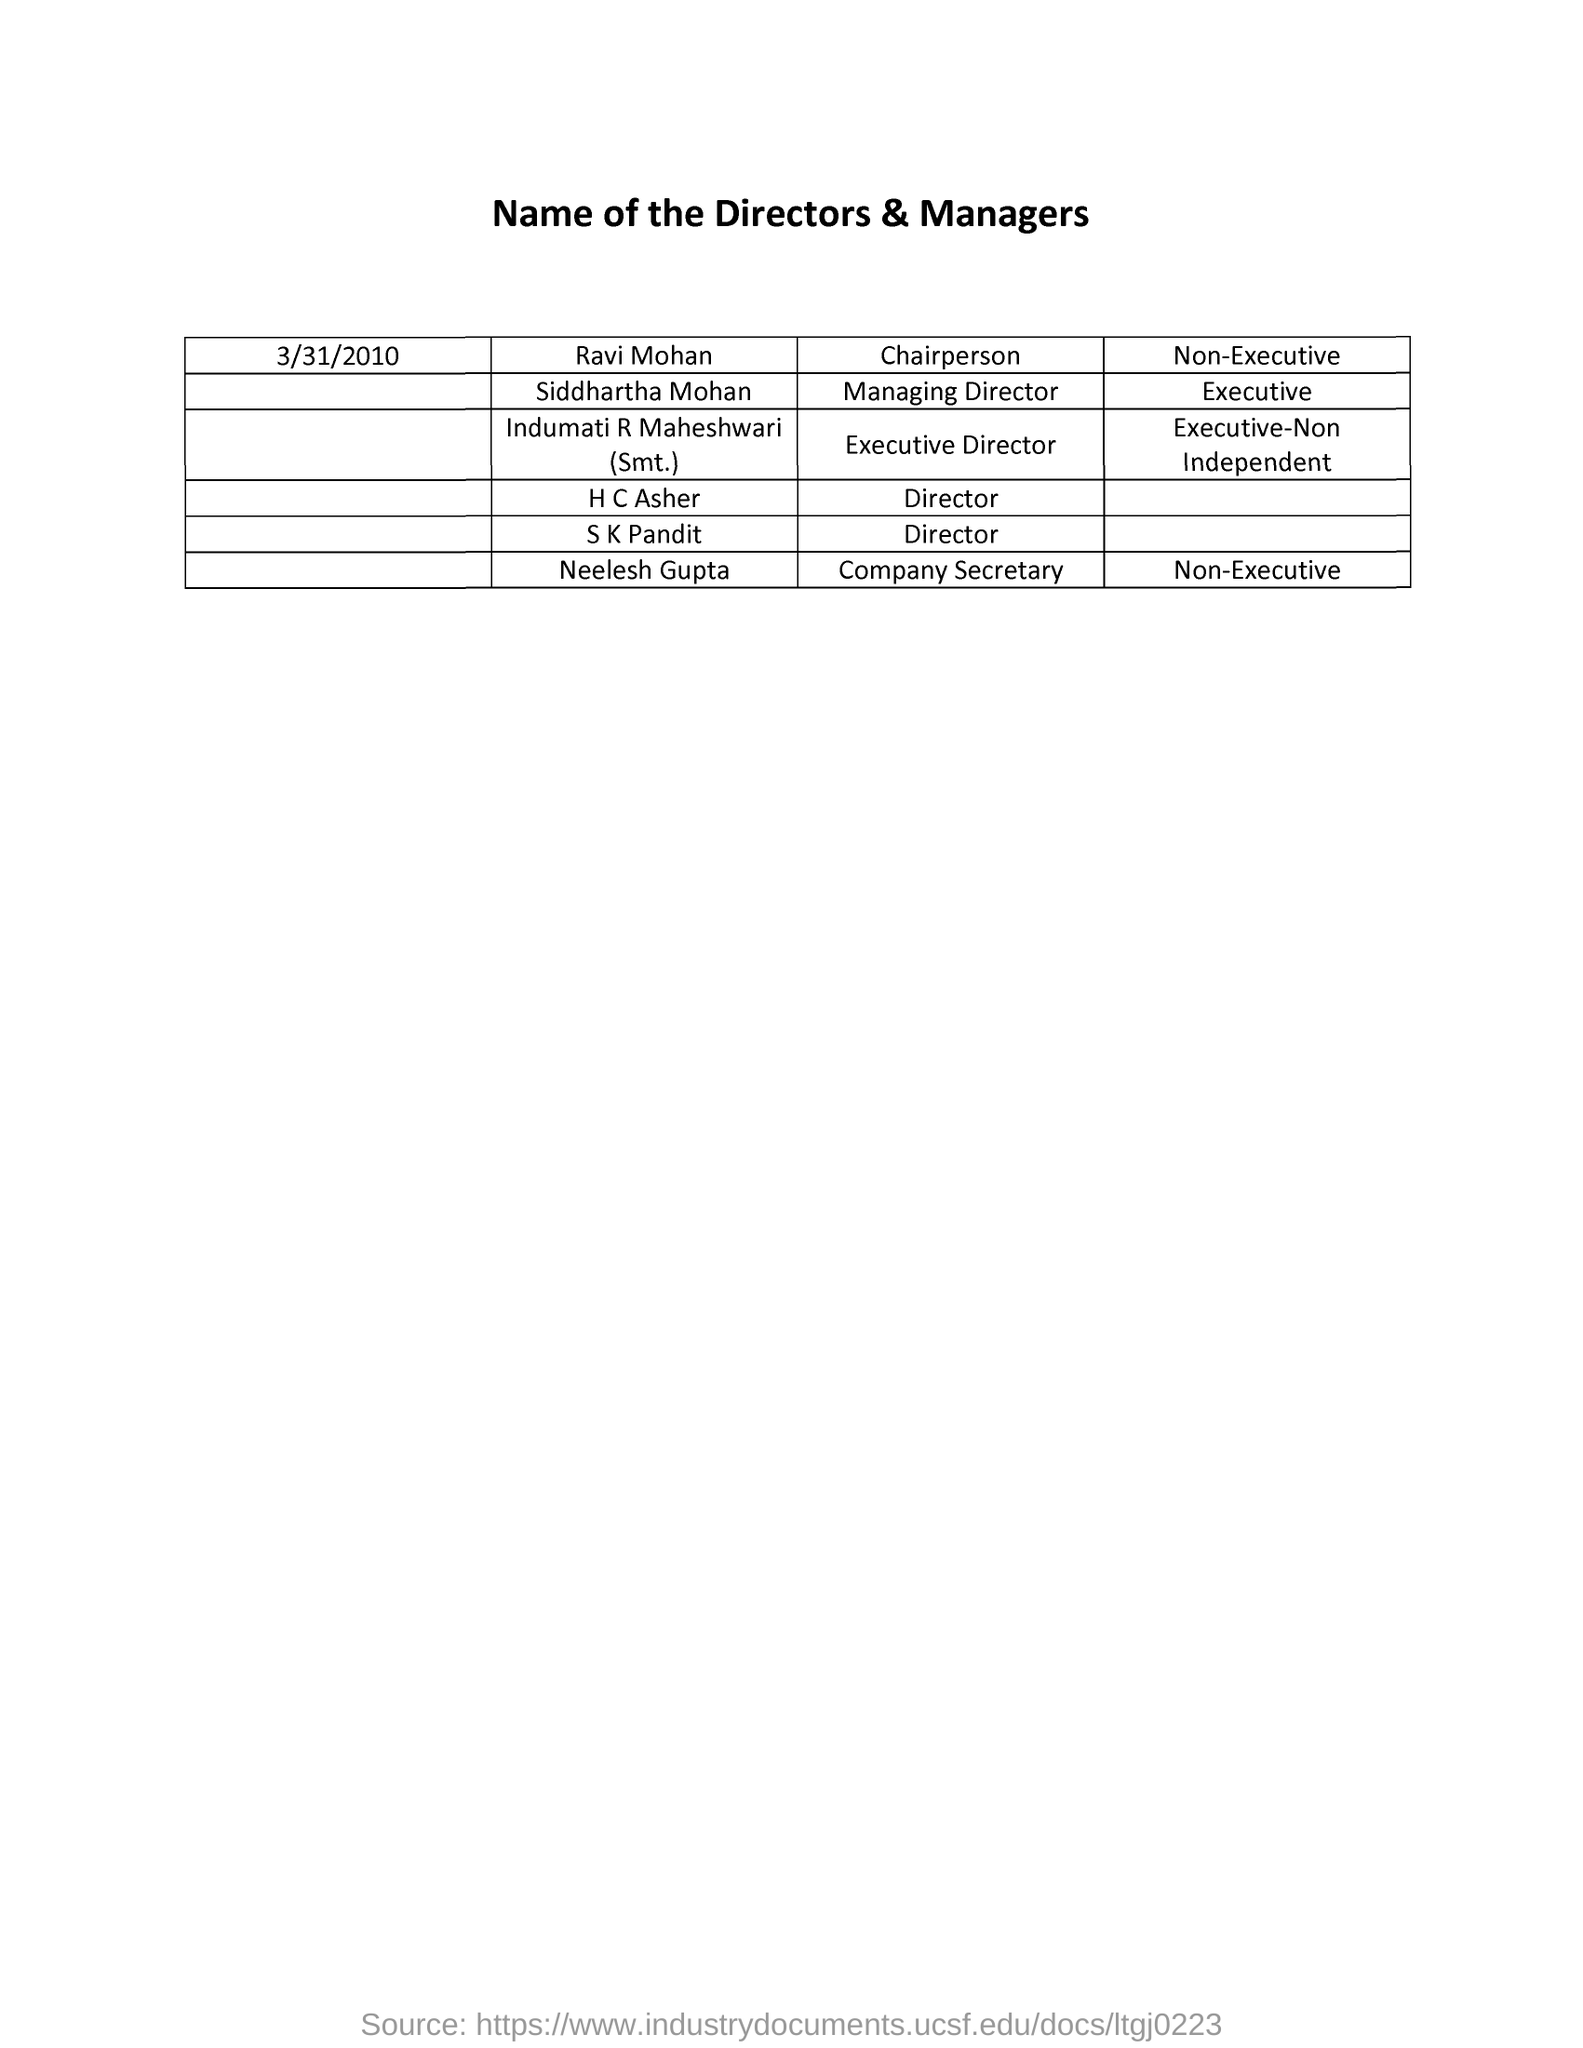Mention a couple of crucial points in this snapshot. The Memorandum is dated on March 31, 2010. The title of the document is [insert title], and the names of the directors and managers are [insert names]. The person named Neelesh Gupta is the Company Secretary. The person named Ravi Mohan is the Chairperson. The Managing Director is Siddhartha Mohan. 